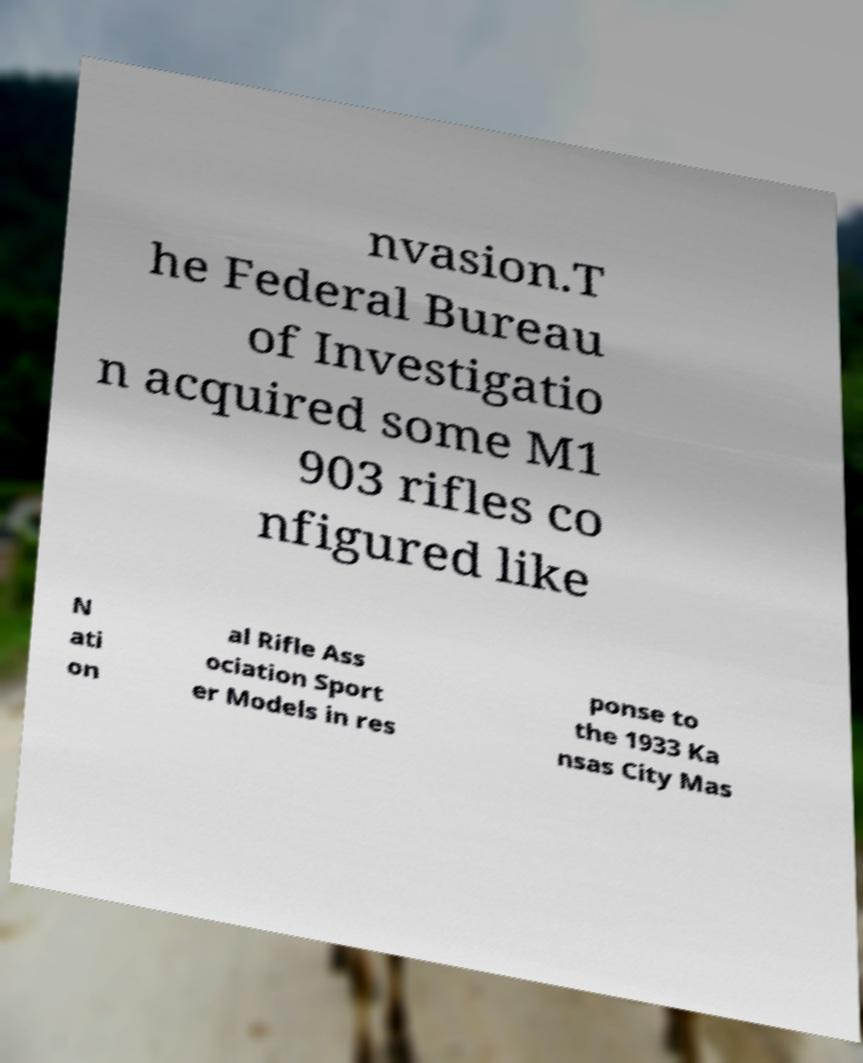Please identify and transcribe the text found in this image. nvasion.T he Federal Bureau of Investigatio n acquired some M1 903 rifles co nfigured like N ati on al Rifle Ass ociation Sport er Models in res ponse to the 1933 Ka nsas City Mas 